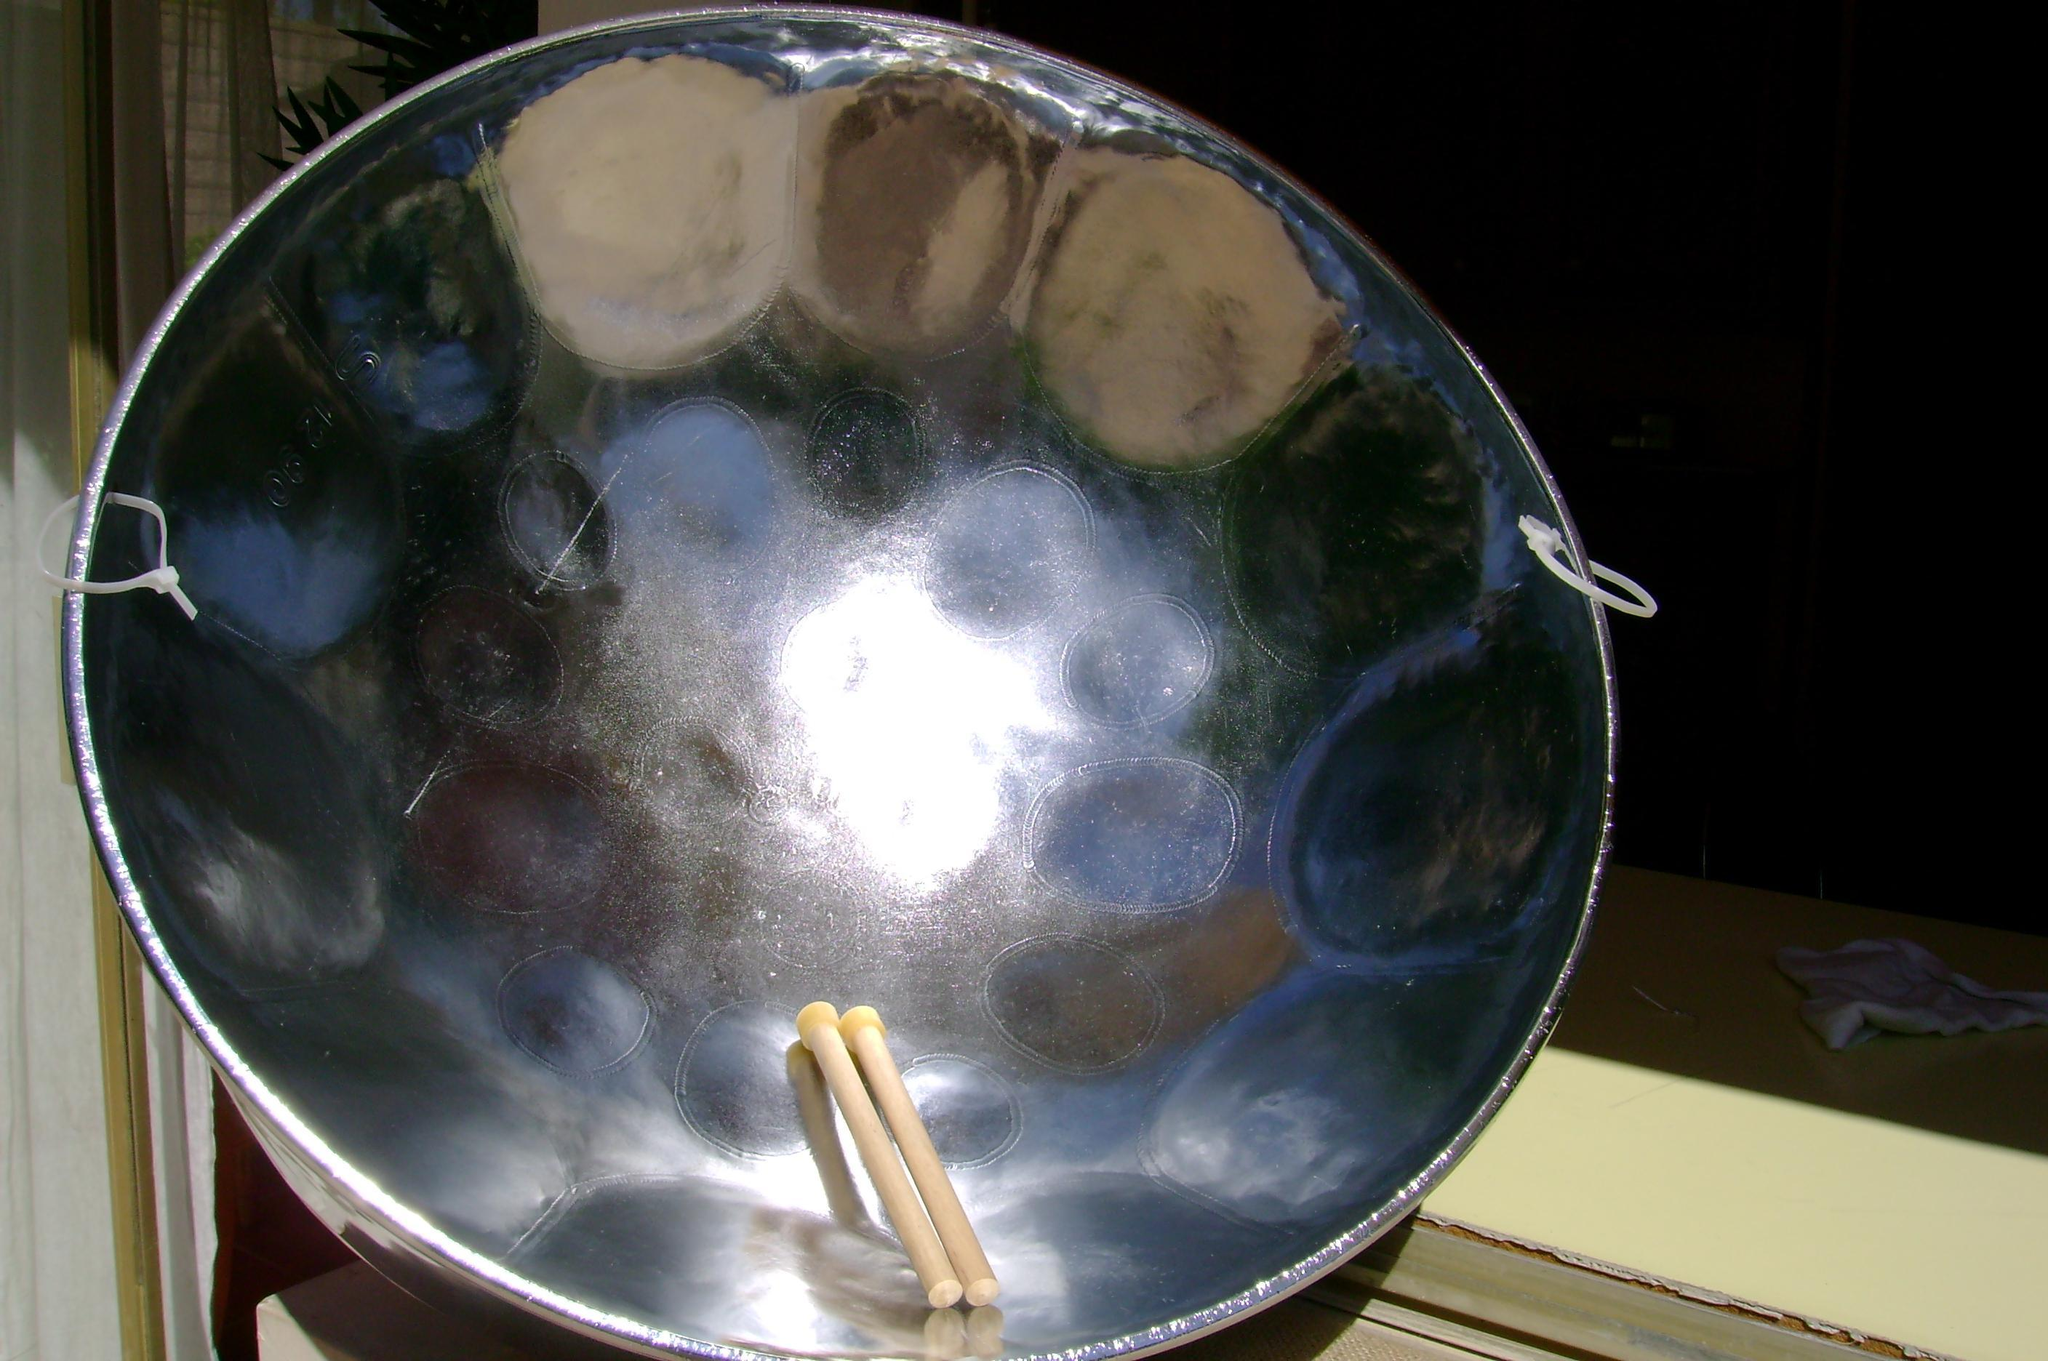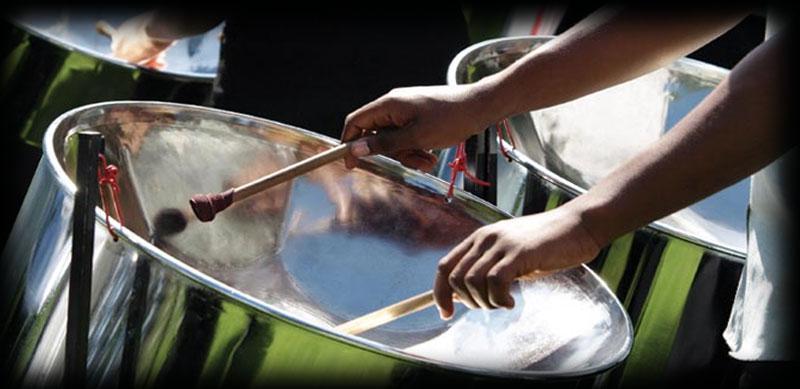The first image is the image on the left, the second image is the image on the right. Given the left and right images, does the statement "Two hands belonging to someone wearing a hawaiaan shirt are holding drumsticks over the concave bowl of a steel drum in one image, and the other image shows the bowl of at least one drum with no drumsticks in it." hold true? Answer yes or no. No. 